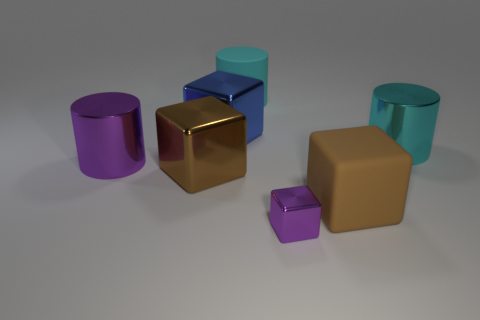Subtract all large brown matte cubes. How many cubes are left? 3 Subtract 1 cubes. How many cubes are left? 3 Subtract all blue blocks. How many blocks are left? 3 Add 3 tiny shiny things. How many objects exist? 10 Subtract all green blocks. Subtract all yellow balls. How many blocks are left? 4 Subtract all cylinders. How many objects are left? 4 Subtract all big yellow rubber objects. Subtract all small cubes. How many objects are left? 6 Add 3 big blue blocks. How many big blue blocks are left? 4 Add 1 purple shiny cylinders. How many purple shiny cylinders exist? 2 Subtract 2 cyan cylinders. How many objects are left? 5 